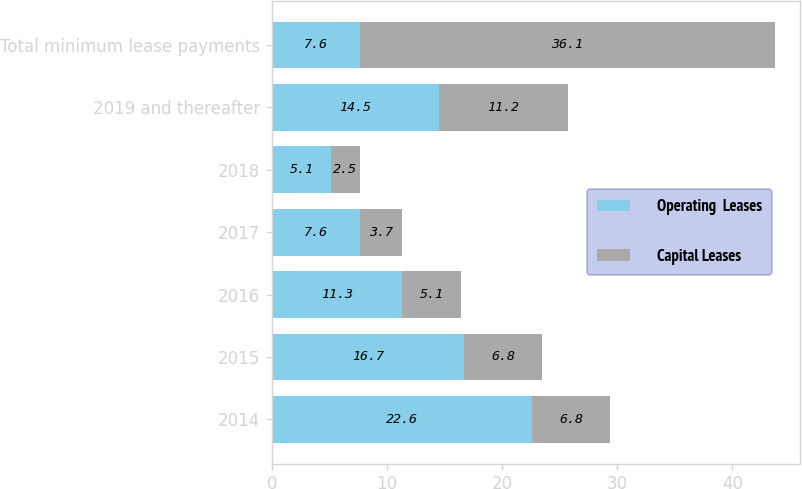Convert chart. <chart><loc_0><loc_0><loc_500><loc_500><stacked_bar_chart><ecel><fcel>2014<fcel>2015<fcel>2016<fcel>2017<fcel>2018<fcel>2019 and thereafter<fcel>Total minimum lease payments<nl><fcel>Operating  Leases<fcel>22.6<fcel>16.7<fcel>11.3<fcel>7.6<fcel>5.1<fcel>14.5<fcel>7.6<nl><fcel>Capital Leases<fcel>6.8<fcel>6.8<fcel>5.1<fcel>3.7<fcel>2.5<fcel>11.2<fcel>36.1<nl></chart> 